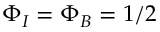Convert formula to latex. <formula><loc_0><loc_0><loc_500><loc_500>\Phi _ { I } = \Phi _ { B } = 1 / 2</formula> 